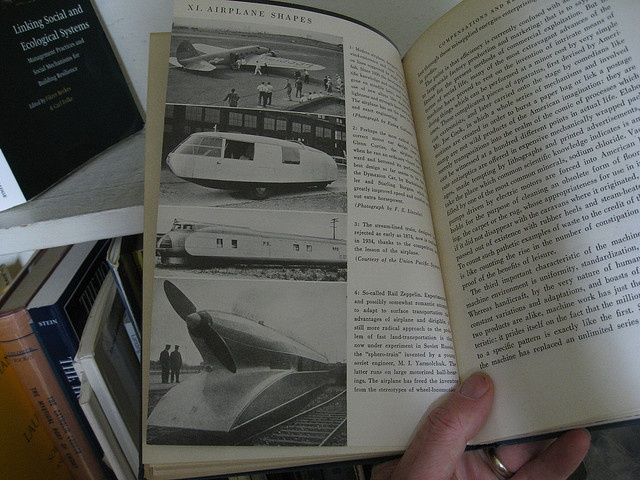Describe the objects in this image and their specific colors. I can see book in gray, black, and darkgray tones, book in black, purple, lavender, and lightblue tones, people in black, maroon, and brown tones, book in black, maroon, and gray tones, and book in black and gray tones in this image. 